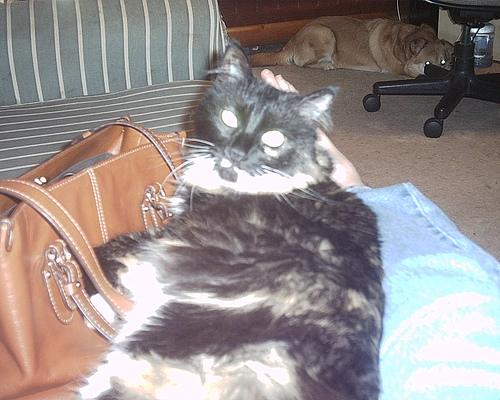What color are the dog's eyes?
Answer briefly. White. What is the cat sitting on?
Answer briefly. Purse. What human body part is sticking out between the cat's ears?
Be succinct. Toe. 